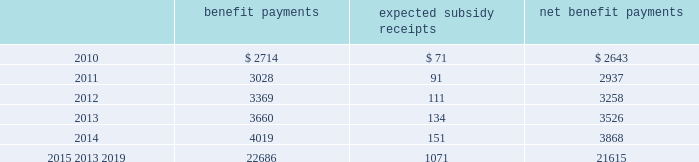Mastercard incorporated notes to consolidated financial statements 2014 ( continued ) ( in thousands , except percent and per share data ) the company does not make any contributions to its postretirement plan other than funding benefits payments .
The table summarizes expected net benefit payments from the company 2019s general assets through 2019 : benefit payments expected subsidy receipts benefit payments .
The company provides limited postemployment benefits to eligible former u.s .
Employees , primarily severance under a formal severance plan ( the 201cseverance plan 201d ) .
The company accounts for severance expense by accruing the expected cost of the severance benefits expected to be provided to former employees after employment over their relevant service periods .
The company updates the assumptions in determining the severance accrual by evaluating the actual severance activity and long-term trends underlying the assumptions .
As a result of updating the assumptions , the company recorded incremental severance expense ( benefit ) related to the severance plan of $ 3471 , $ 2643 and $ ( 3418 ) , respectively , during the years 2009 , 2008 and 2007 .
These amounts were part of total severance expenses of $ 135113 , $ 32997 and $ 21284 in 2009 , 2008 and 2007 , respectively , included in general and administrative expenses in the accompanying consolidated statements of operations .
Note 14 .
Debt on april 28 , 2008 , the company extended its committed unsecured revolving credit facility , dated as of april 28 , 2006 ( the 201ccredit facility 201d ) , for an additional year .
The new expiration date of the credit facility is april 26 , 2011 .
The available funding under the credit facility will remain at $ 2500000 through april 27 , 2010 and then decrease to $ 2000000 during the final year of the credit facility agreement .
Other terms and conditions in the credit facility remain unchanged .
The company 2019s option to request that each lender under the credit facility extend its commitment was provided pursuant to the original terms of the credit facility agreement .
Borrowings under the facility are available to provide liquidity in the event of one or more settlement failures by mastercard international customers and , subject to a limit of $ 500000 , for general corporate purposes .
The facility fee and borrowing cost are contingent upon the company 2019s credit rating .
At december 31 , 2009 , the facility fee was 7 basis points on the total commitment , or approximately $ 1774 annually .
Interest on borrowings under the credit facility would be charged at the london interbank offered rate ( libor ) plus an applicable margin of 28 basis points or an alternative base rate , and a utilization fee of 10 basis points would be charged if outstanding borrowings under the facility exceed 50% ( 50 % ) of commitments .
At the inception of the credit facility , the company also agreed to pay upfront fees of $ 1250 and administrative fees of $ 325 , which are being amortized over five years .
Facility and other fees associated with the credit facility totaled $ 2222 , $ 2353 and $ 2477 for each of the years ended december 31 , 2009 , 2008 and 2007 , respectively .
Mastercard was in compliance with the covenants of the credit facility and had no borrowings under the credit facility at december 31 , 2009 or december 31 , 2008 .
The majority of credit facility lenders are members or affiliates of members of mastercard international .
In june 1998 , mastercard international issued ten-year unsecured , subordinated notes ( the 201cnotes 201d ) paying a fixed interest rate of 6.67% ( 6.67 % ) per annum .
Mastercard repaid the entire principal amount of $ 80000 on june 30 , 2008 pursuant to the terms of the notes .
The interest expense on the notes was $ 2668 and $ 5336 for each of the years ended december 31 , 2008 and 2007 , respectively. .
What was the percent of the incremental severance expense in 2009? 
Rationale: the incremental severance expense in 2009 were 2.6% of the severance expense
Computations: (3471 / 135113)
Answer: 0.02569. 